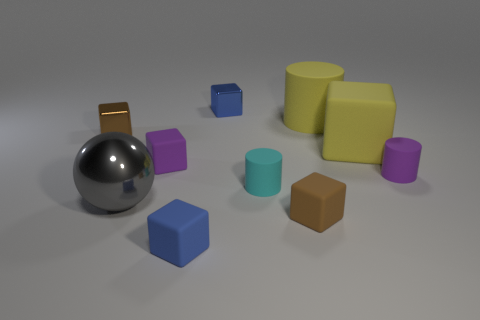Subtract all yellow blocks. How many blocks are left? 5 Subtract all large yellow blocks. How many blocks are left? 5 Subtract all purple cubes. Subtract all purple balls. How many cubes are left? 5 Subtract all cubes. How many objects are left? 4 Add 6 small brown metal cubes. How many small brown metal cubes exist? 7 Subtract 1 yellow cylinders. How many objects are left? 9 Subtract all brown rubber cubes. Subtract all small blue rubber things. How many objects are left? 8 Add 7 purple rubber cubes. How many purple rubber cubes are left? 8 